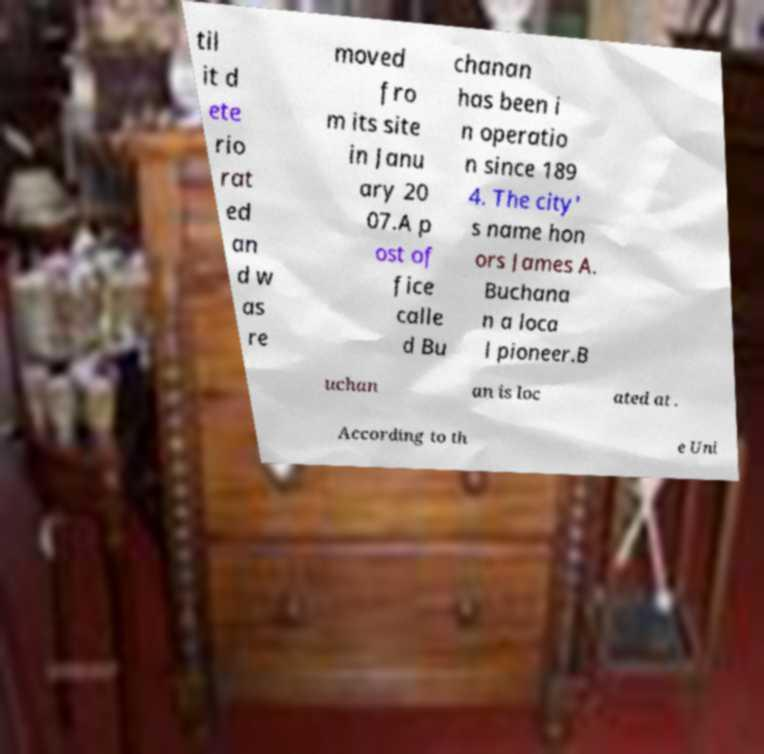Please read and relay the text visible in this image. What does it say? til it d ete rio rat ed an d w as re moved fro m its site in Janu ary 20 07.A p ost of fice calle d Bu chanan has been i n operatio n since 189 4. The city' s name hon ors James A. Buchana n a loca l pioneer.B uchan an is loc ated at . According to th e Uni 